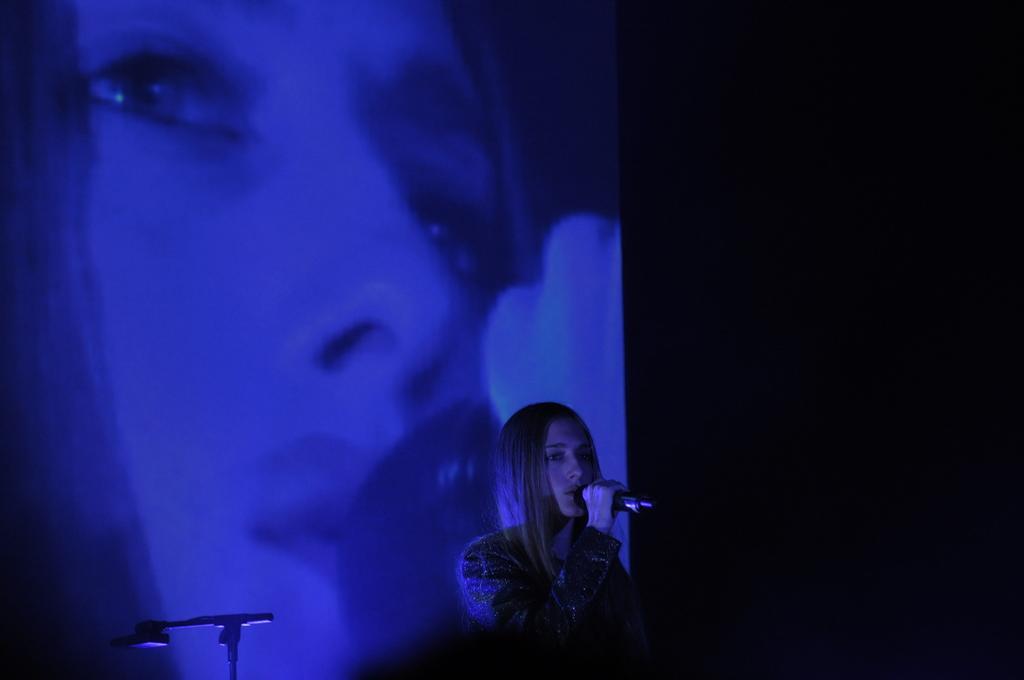Describe this image in one or two sentences. In this image there is a lady holding the mike in her, in the background there is a screen, in that screen there is a picture of a lady. 